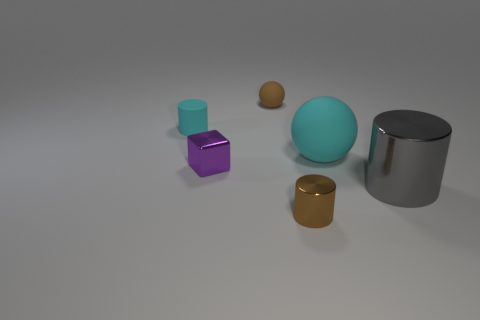Is the tiny rubber ball the same color as the small metallic cylinder?
Provide a short and direct response. Yes. What is the material of the big object right of the cyan thing that is to the right of the metal object behind the large cylinder?
Your answer should be very brief. Metal. What is the size of the metal cylinder on the right side of the cyan object that is on the right side of the tiny metallic cylinder?
Give a very brief answer. Large. There is another rubber object that is the same shape as the brown rubber object; what color is it?
Keep it short and to the point. Cyan. What number of matte cylinders have the same color as the small metal cylinder?
Give a very brief answer. 0. Is the size of the brown shiny thing the same as the cyan sphere?
Give a very brief answer. No. What material is the big cyan ball?
Provide a succinct answer. Rubber. There is a cylinder that is made of the same material as the large cyan sphere; what color is it?
Make the answer very short. Cyan. Is the big cyan thing made of the same material as the small object that is to the left of the purple shiny block?
Keep it short and to the point. Yes. How many tiny purple objects are made of the same material as the cyan cylinder?
Keep it short and to the point. 0. 